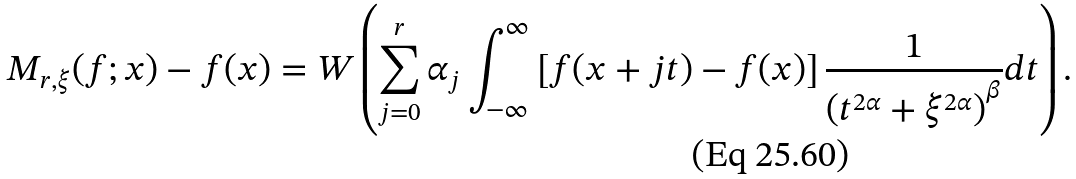Convert formula to latex. <formula><loc_0><loc_0><loc_500><loc_500>M _ { r , \xi } ( f ; x ) - f ( x ) = W \left ( \sum _ { j = 0 } ^ { r } \alpha _ { j } \int _ { - \infty } ^ { \infty } \left [ f ( x + j t ) - f ( x ) \right ] \frac { 1 } { \left ( t ^ { 2 \alpha } + \xi ^ { 2 \alpha } \right ) ^ { \beta } } d t \right ) .</formula> 